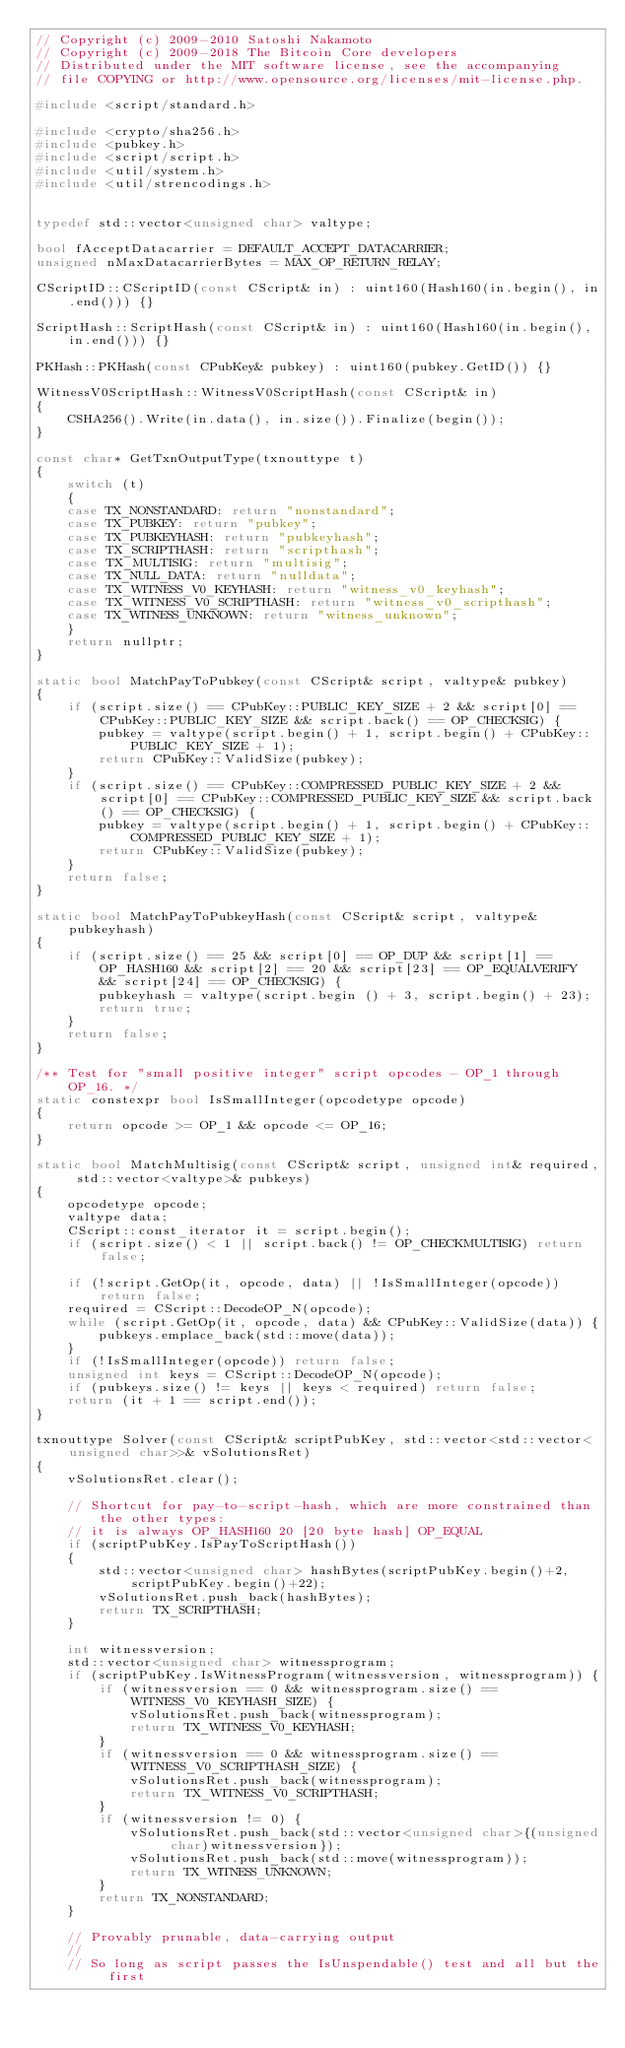<code> <loc_0><loc_0><loc_500><loc_500><_C++_>// Copyright (c) 2009-2010 Satoshi Nakamoto
// Copyright (c) 2009-2018 The Bitcoin Core developers
// Distributed under the MIT software license, see the accompanying
// file COPYING or http://www.opensource.org/licenses/mit-license.php.

#include <script/standard.h>

#include <crypto/sha256.h>
#include <pubkey.h>
#include <script/script.h>
#include <util/system.h>
#include <util/strencodings.h>


typedef std::vector<unsigned char> valtype;

bool fAcceptDatacarrier = DEFAULT_ACCEPT_DATACARRIER;
unsigned nMaxDatacarrierBytes = MAX_OP_RETURN_RELAY;

CScriptID::CScriptID(const CScript& in) : uint160(Hash160(in.begin(), in.end())) {}

ScriptHash::ScriptHash(const CScript& in) : uint160(Hash160(in.begin(), in.end())) {}

PKHash::PKHash(const CPubKey& pubkey) : uint160(pubkey.GetID()) {}

WitnessV0ScriptHash::WitnessV0ScriptHash(const CScript& in)
{
    CSHA256().Write(in.data(), in.size()).Finalize(begin());
}

const char* GetTxnOutputType(txnouttype t)
{
    switch (t)
    {
    case TX_NONSTANDARD: return "nonstandard";
    case TX_PUBKEY: return "pubkey";
    case TX_PUBKEYHASH: return "pubkeyhash";
    case TX_SCRIPTHASH: return "scripthash";
    case TX_MULTISIG: return "multisig";
    case TX_NULL_DATA: return "nulldata";
    case TX_WITNESS_V0_KEYHASH: return "witness_v0_keyhash";
    case TX_WITNESS_V0_SCRIPTHASH: return "witness_v0_scripthash";
    case TX_WITNESS_UNKNOWN: return "witness_unknown";
    }
    return nullptr;
}

static bool MatchPayToPubkey(const CScript& script, valtype& pubkey)
{
    if (script.size() == CPubKey::PUBLIC_KEY_SIZE + 2 && script[0] == CPubKey::PUBLIC_KEY_SIZE && script.back() == OP_CHECKSIG) {
        pubkey = valtype(script.begin() + 1, script.begin() + CPubKey::PUBLIC_KEY_SIZE + 1);
        return CPubKey::ValidSize(pubkey);
    }
    if (script.size() == CPubKey::COMPRESSED_PUBLIC_KEY_SIZE + 2 && script[0] == CPubKey::COMPRESSED_PUBLIC_KEY_SIZE && script.back() == OP_CHECKSIG) {
        pubkey = valtype(script.begin() + 1, script.begin() + CPubKey::COMPRESSED_PUBLIC_KEY_SIZE + 1);
        return CPubKey::ValidSize(pubkey);
    }
    return false;
}

static bool MatchPayToPubkeyHash(const CScript& script, valtype& pubkeyhash)
{
    if (script.size() == 25 && script[0] == OP_DUP && script[1] == OP_HASH160 && script[2] == 20 && script[23] == OP_EQUALVERIFY && script[24] == OP_CHECKSIG) {
        pubkeyhash = valtype(script.begin () + 3, script.begin() + 23);
        return true;
    }
    return false;
}

/** Test for "small positive integer" script opcodes - OP_1 through OP_16. */
static constexpr bool IsSmallInteger(opcodetype opcode)
{
    return opcode >= OP_1 && opcode <= OP_16;
}

static bool MatchMultisig(const CScript& script, unsigned int& required, std::vector<valtype>& pubkeys)
{
    opcodetype opcode;
    valtype data;
    CScript::const_iterator it = script.begin();
    if (script.size() < 1 || script.back() != OP_CHECKMULTISIG) return false;

    if (!script.GetOp(it, opcode, data) || !IsSmallInteger(opcode)) return false;
    required = CScript::DecodeOP_N(opcode);
    while (script.GetOp(it, opcode, data) && CPubKey::ValidSize(data)) {
        pubkeys.emplace_back(std::move(data));
    }
    if (!IsSmallInteger(opcode)) return false;
    unsigned int keys = CScript::DecodeOP_N(opcode);
    if (pubkeys.size() != keys || keys < required) return false;
    return (it + 1 == script.end());
}

txnouttype Solver(const CScript& scriptPubKey, std::vector<std::vector<unsigned char>>& vSolutionsRet)
{
    vSolutionsRet.clear();

    // Shortcut for pay-to-script-hash, which are more constrained than the other types:
    // it is always OP_HASH160 20 [20 byte hash] OP_EQUAL
    if (scriptPubKey.IsPayToScriptHash())
    {
        std::vector<unsigned char> hashBytes(scriptPubKey.begin()+2, scriptPubKey.begin()+22);
        vSolutionsRet.push_back(hashBytes);
        return TX_SCRIPTHASH;
    }

    int witnessversion;
    std::vector<unsigned char> witnessprogram;
    if (scriptPubKey.IsWitnessProgram(witnessversion, witnessprogram)) {
        if (witnessversion == 0 && witnessprogram.size() == WITNESS_V0_KEYHASH_SIZE) {
            vSolutionsRet.push_back(witnessprogram);
            return TX_WITNESS_V0_KEYHASH;
        }
        if (witnessversion == 0 && witnessprogram.size() == WITNESS_V0_SCRIPTHASH_SIZE) {
            vSolutionsRet.push_back(witnessprogram);
            return TX_WITNESS_V0_SCRIPTHASH;
        }
        if (witnessversion != 0) {
            vSolutionsRet.push_back(std::vector<unsigned char>{(unsigned char)witnessversion});
            vSolutionsRet.push_back(std::move(witnessprogram));
            return TX_WITNESS_UNKNOWN;
        }
        return TX_NONSTANDARD;
    }

    // Provably prunable, data-carrying output
    //
    // So long as script passes the IsUnspendable() test and all but the first</code> 